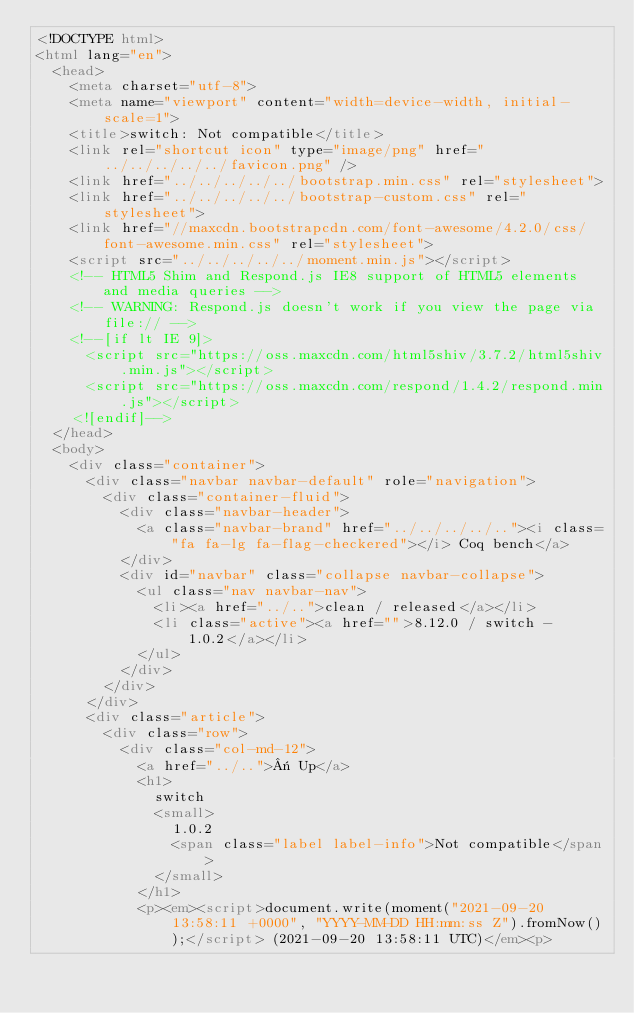Convert code to text. <code><loc_0><loc_0><loc_500><loc_500><_HTML_><!DOCTYPE html>
<html lang="en">
  <head>
    <meta charset="utf-8">
    <meta name="viewport" content="width=device-width, initial-scale=1">
    <title>switch: Not compatible</title>
    <link rel="shortcut icon" type="image/png" href="../../../../../favicon.png" />
    <link href="../../../../../bootstrap.min.css" rel="stylesheet">
    <link href="../../../../../bootstrap-custom.css" rel="stylesheet">
    <link href="//maxcdn.bootstrapcdn.com/font-awesome/4.2.0/css/font-awesome.min.css" rel="stylesheet">
    <script src="../../../../../moment.min.js"></script>
    <!-- HTML5 Shim and Respond.js IE8 support of HTML5 elements and media queries -->
    <!-- WARNING: Respond.js doesn't work if you view the page via file:// -->
    <!--[if lt IE 9]>
      <script src="https://oss.maxcdn.com/html5shiv/3.7.2/html5shiv.min.js"></script>
      <script src="https://oss.maxcdn.com/respond/1.4.2/respond.min.js"></script>
    <![endif]-->
  </head>
  <body>
    <div class="container">
      <div class="navbar navbar-default" role="navigation">
        <div class="container-fluid">
          <div class="navbar-header">
            <a class="navbar-brand" href="../../../../.."><i class="fa fa-lg fa-flag-checkered"></i> Coq bench</a>
          </div>
          <div id="navbar" class="collapse navbar-collapse">
            <ul class="nav navbar-nav">
              <li><a href="../..">clean / released</a></li>
              <li class="active"><a href="">8.12.0 / switch - 1.0.2</a></li>
            </ul>
          </div>
        </div>
      </div>
      <div class="article">
        <div class="row">
          <div class="col-md-12">
            <a href="../..">« Up</a>
            <h1>
              switch
              <small>
                1.0.2
                <span class="label label-info">Not compatible</span>
              </small>
            </h1>
            <p><em><script>document.write(moment("2021-09-20 13:58:11 +0000", "YYYY-MM-DD HH:mm:ss Z").fromNow());</script> (2021-09-20 13:58:11 UTC)</em><p></code> 